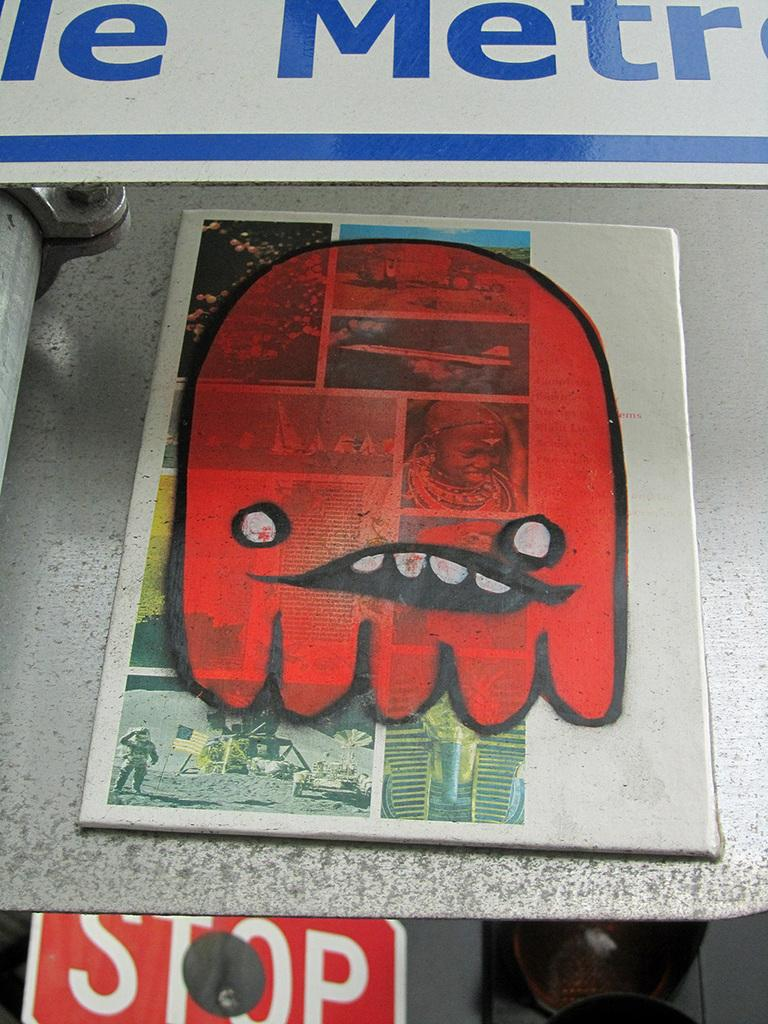<image>
Provide a brief description of the given image. a red figure above a stop sign on a paper 